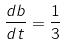<formula> <loc_0><loc_0><loc_500><loc_500>\frac { d b } { d t } = \frac { 1 } { 3 }</formula> 